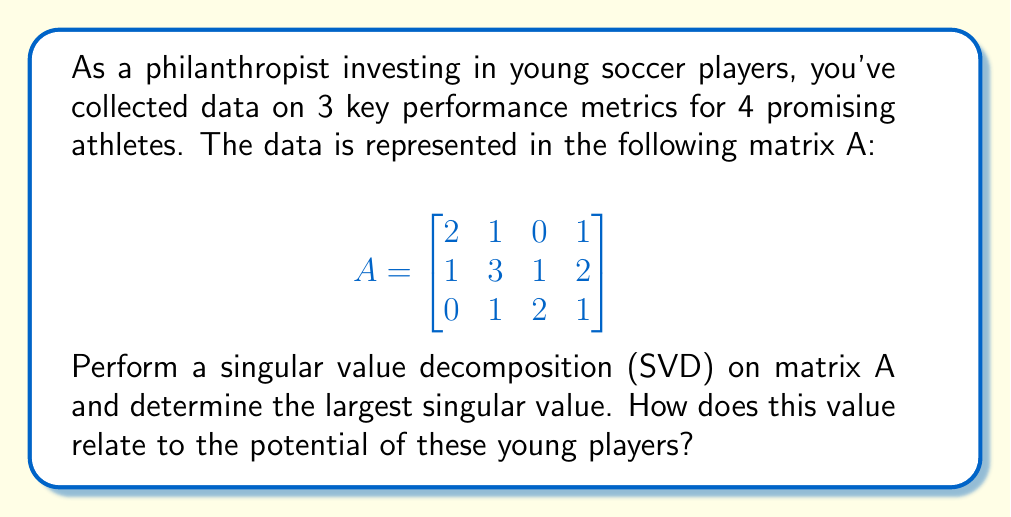Can you answer this question? To perform the singular value decomposition (SVD) on matrix A, we need to find matrices U, Σ, and V* such that A = UΣV*. Here's the step-by-step process:

1) First, calculate A*A and AA*:

   $$A^TA = \begin{bmatrix}
   5 & 7 & 3 & 6 \\
   7 & 11 & 5 & 9 \\
   3 & 5 & 5 & 5 \\
   6 & 9 & 5 & 6
   \end{bmatrix}$$

   $$AA^T = \begin{bmatrix}
   6 & 7 & 2 \\
   7 & 14 & 5 \\
   2 & 5 & 6
   \end{bmatrix}$$

2) Find the eigenvalues of A*A (which are the same as the squares of the singular values):
   
   Characteristic equation: $\det(A^TA - \lambda I) = 0$
   
   Solving this equation gives us:
   $\lambda_1 \approx 25.0468$
   $\lambda_2 \approx 1.8799$
   $\lambda_3 \approx 0.0733$
   $\lambda_4 = 0$

3) The singular values are the square roots of these eigenvalues:
   
   $\sigma_1 \approx 5.0047$
   $\sigma_2 \approx 1.3711$
   $\sigma_3 \approx 0.2707$
   $\sigma_4 = 0$

4) The largest singular value is $\sigma_1 \approx 5.0047$.

5) In terms of player potential, the largest singular value represents the most significant pattern or trend in the data. A higher value indicates stronger correlations between the performance metrics and suggests that these young players have consistent, high-level performances across multiple areas. This implies a good overall potential for the group of players.
Answer: $\sigma_1 \approx 5.0047$; indicates strong overall potential 